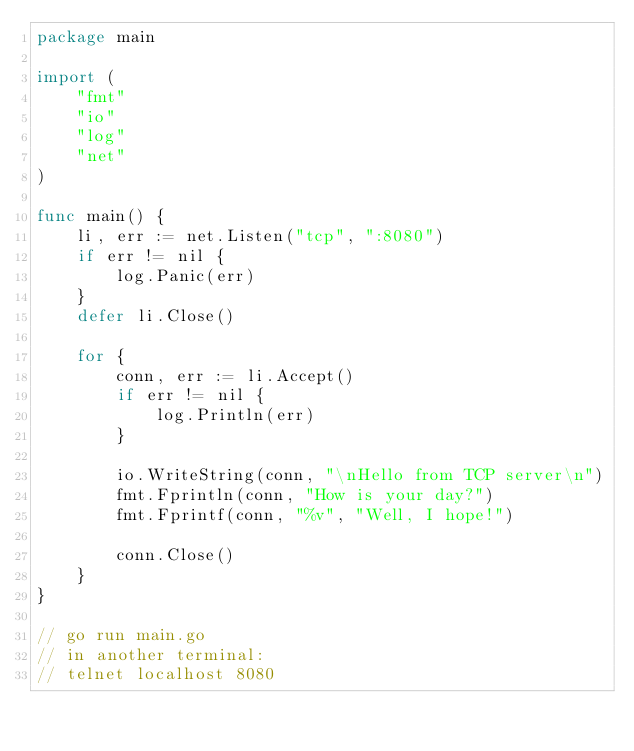<code> <loc_0><loc_0><loc_500><loc_500><_Go_>package main

import (
	"fmt"
	"io"
	"log"
	"net"
)

func main() {
	li, err := net.Listen("tcp", ":8080")
	if err != nil {
		log.Panic(err)
	}
	defer li.Close()

	for {
		conn, err := li.Accept()
		if err != nil {
			log.Println(err)
		}

		io.WriteString(conn, "\nHello from TCP server\n")
		fmt.Fprintln(conn, "How is your day?")
		fmt.Fprintf(conn, "%v", "Well, I hope!")

		conn.Close()
	}
}

// go run main.go
// in another terminal:
// telnet localhost 8080
</code> 